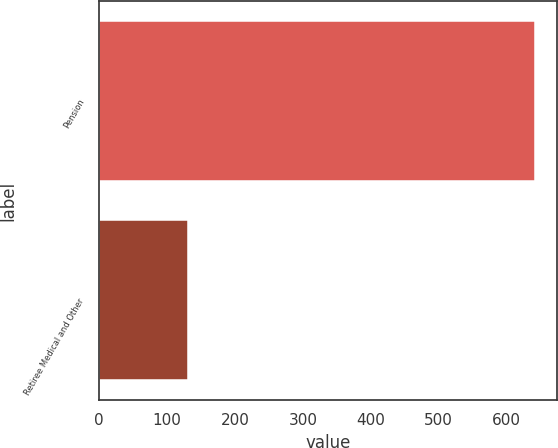<chart> <loc_0><loc_0><loc_500><loc_500><bar_chart><fcel>Pension<fcel>Retiree Medical and Other<nl><fcel>642<fcel>130<nl></chart> 